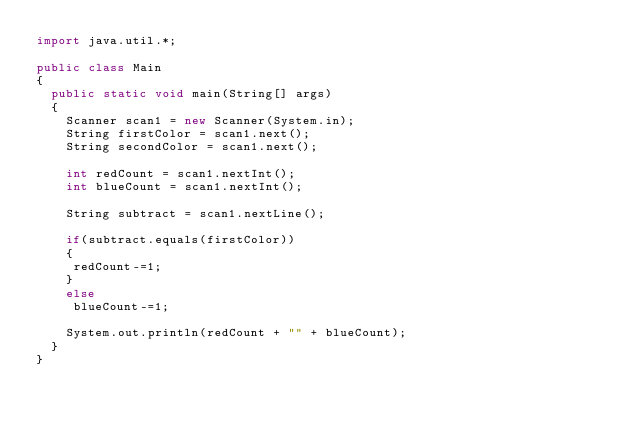<code> <loc_0><loc_0><loc_500><loc_500><_Java_>import java.util.*;
 
public class Main
{
  public static void main(String[] args)
  {
    Scanner scan1 = new Scanner(System.in);
	String firstColor = scan1.next();
    String secondColor = scan1.next();
 
	int redCount = scan1.nextInt();
	int blueCount = scan1.nextInt();
 
	String subtract = scan1.nextLine();
 
	if(subtract.equals(firstColor))
	{
 	 redCount-=1;
	}
	else
 	 blueCount-=1;
 
	System.out.println(redCount + "" + blueCount);
  }
}</code> 